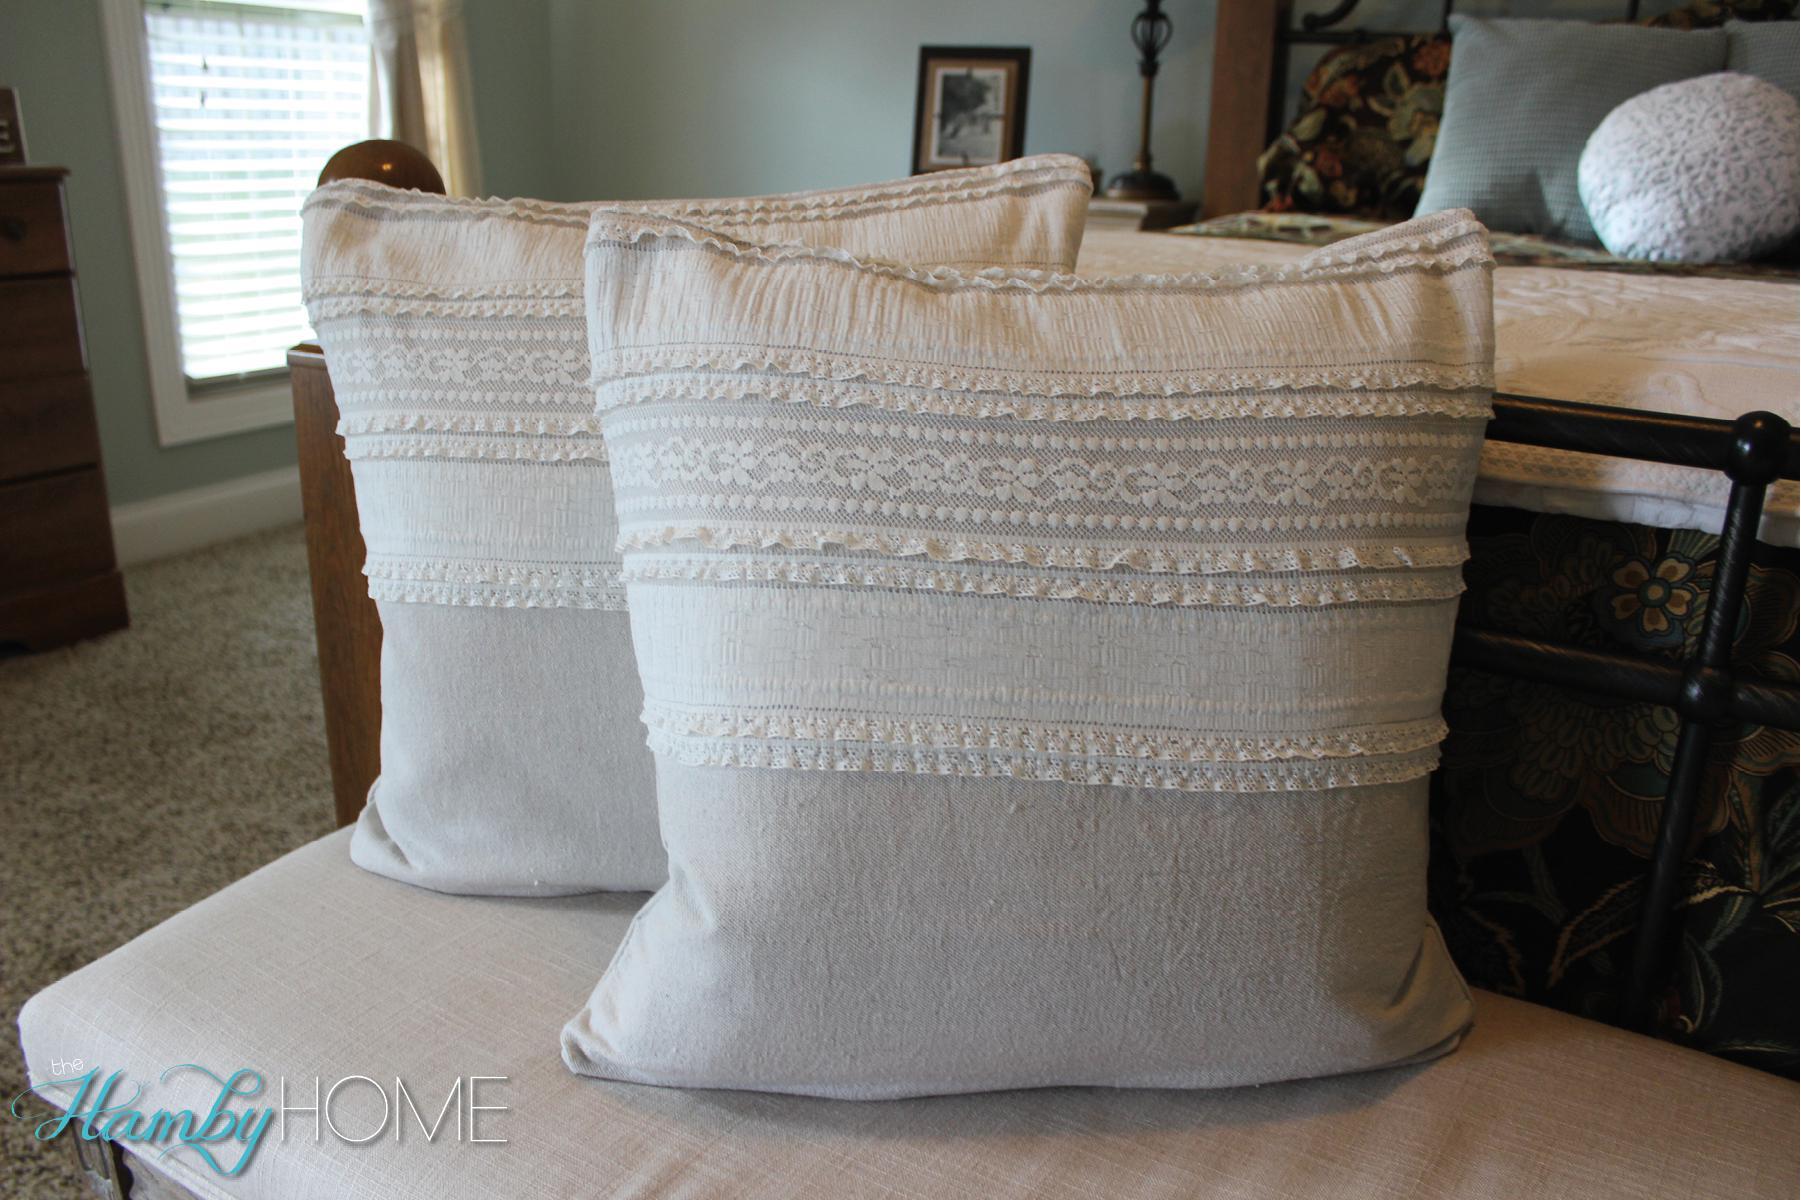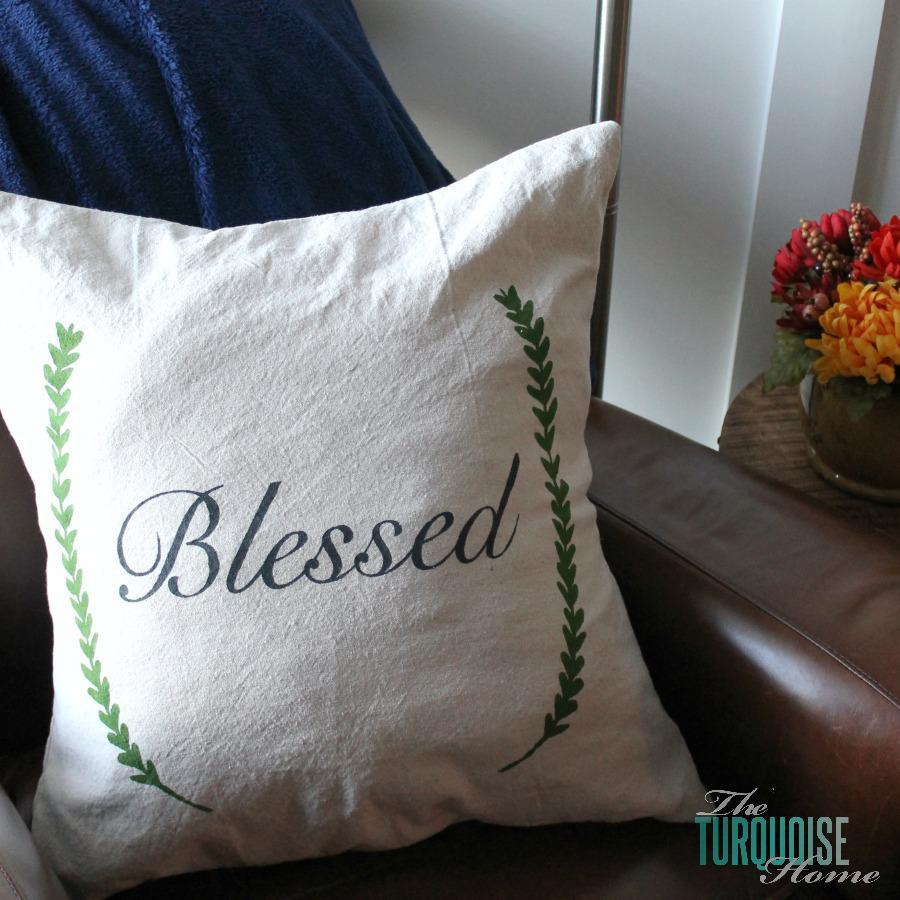The first image is the image on the left, the second image is the image on the right. Assess this claim about the two images: "An image features a square pillow with multiple rows of ruffles across its front.". Correct or not? Answer yes or no. Yes. 